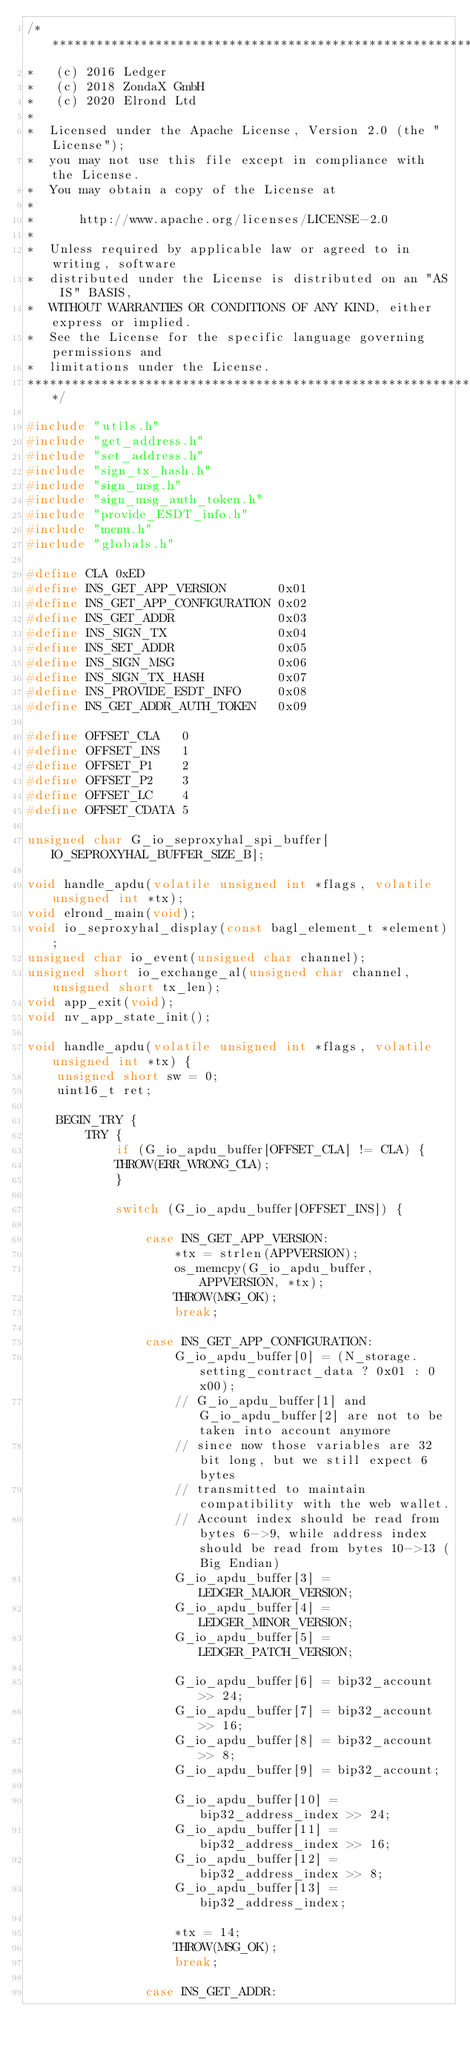<code> <loc_0><loc_0><loc_500><loc_500><_C_>/*******************************************************************************
*   (c) 2016 Ledger
*   (c) 2018 ZondaX GmbH
*   (c) 2020 Elrond Ltd
*
*  Licensed under the Apache License, Version 2.0 (the "License");
*  you may not use this file except in compliance with the License.
*  You may obtain a copy of the License at
*
*      http://www.apache.org/licenses/LICENSE-2.0
*
*  Unless required by applicable law or agreed to in writing, software
*  distributed under the License is distributed on an "AS IS" BASIS,
*  WITHOUT WARRANTIES OR CONDITIONS OF ANY KIND, either express or implied.
*  See the License for the specific language governing permissions and
*  limitations under the License.
********************************************************************************/

#include "utils.h"
#include "get_address.h"
#include "set_address.h"
#include "sign_tx_hash.h"
#include "sign_msg.h"
#include "sign_msg_auth_token.h"
#include "provide_ESDT_info.h"
#include "menu.h"
#include "globals.h"

#define CLA 0xED
#define INS_GET_APP_VERSION       0x01
#define INS_GET_APP_CONFIGURATION 0x02
#define INS_GET_ADDR              0x03
#define INS_SIGN_TX               0x04
#define INS_SET_ADDR              0x05
#define INS_SIGN_MSG              0x06
#define INS_SIGN_TX_HASH          0x07
#define INS_PROVIDE_ESDT_INFO     0x08
#define INS_GET_ADDR_AUTH_TOKEN   0x09

#define OFFSET_CLA   0
#define OFFSET_INS   1
#define OFFSET_P1    2
#define OFFSET_P2    3
#define OFFSET_LC    4
#define OFFSET_CDATA 5

unsigned char G_io_seproxyhal_spi_buffer[IO_SEPROXYHAL_BUFFER_SIZE_B];

void handle_apdu(volatile unsigned int *flags, volatile unsigned int *tx);
void elrond_main(void);
void io_seproxyhal_display(const bagl_element_t *element);
unsigned char io_event(unsigned char channel);
unsigned short io_exchange_al(unsigned char channel, unsigned short tx_len);
void app_exit(void);
void nv_app_state_init();

void handle_apdu(volatile unsigned int *flags, volatile unsigned int *tx) {
    unsigned short sw = 0;
    uint16_t ret;

    BEGIN_TRY {
        TRY {
            if (G_io_apdu_buffer[OFFSET_CLA] != CLA) {
            THROW(ERR_WRONG_CLA);
            }

            switch (G_io_apdu_buffer[OFFSET_INS]) {

                case INS_GET_APP_VERSION:
                    *tx = strlen(APPVERSION);
                    os_memcpy(G_io_apdu_buffer, APPVERSION, *tx);
                    THROW(MSG_OK);
                    break;

                case INS_GET_APP_CONFIGURATION:
                    G_io_apdu_buffer[0] = (N_storage.setting_contract_data ? 0x01 : 0x00);
                    // G_io_apdu_buffer[1] and G_io_apdu_buffer[2] are not to be taken into account anymore
                    // since now those variables are 32 bit long, but we still expect 6 bytes
                    // transmitted to maintain compatibility with the web wallet.
                    // Account index should be read from bytes 6->9, while address index should be read from bytes 10->13 (Big Endian)
                    G_io_apdu_buffer[3] = LEDGER_MAJOR_VERSION;
                    G_io_apdu_buffer[4] = LEDGER_MINOR_VERSION;
                    G_io_apdu_buffer[5] = LEDGER_PATCH_VERSION;

                    G_io_apdu_buffer[6] = bip32_account >> 24;
                    G_io_apdu_buffer[7] = bip32_account >> 16;
                    G_io_apdu_buffer[8] = bip32_account >> 8;
                    G_io_apdu_buffer[9] = bip32_account;

                    G_io_apdu_buffer[10] = bip32_address_index >> 24;
                    G_io_apdu_buffer[11] = bip32_address_index >> 16;
                    G_io_apdu_buffer[12] = bip32_address_index >> 8;
                    G_io_apdu_buffer[13] = bip32_address_index;

                    *tx = 14;
                    THROW(MSG_OK);
                    break;

                case INS_GET_ADDR:</code> 